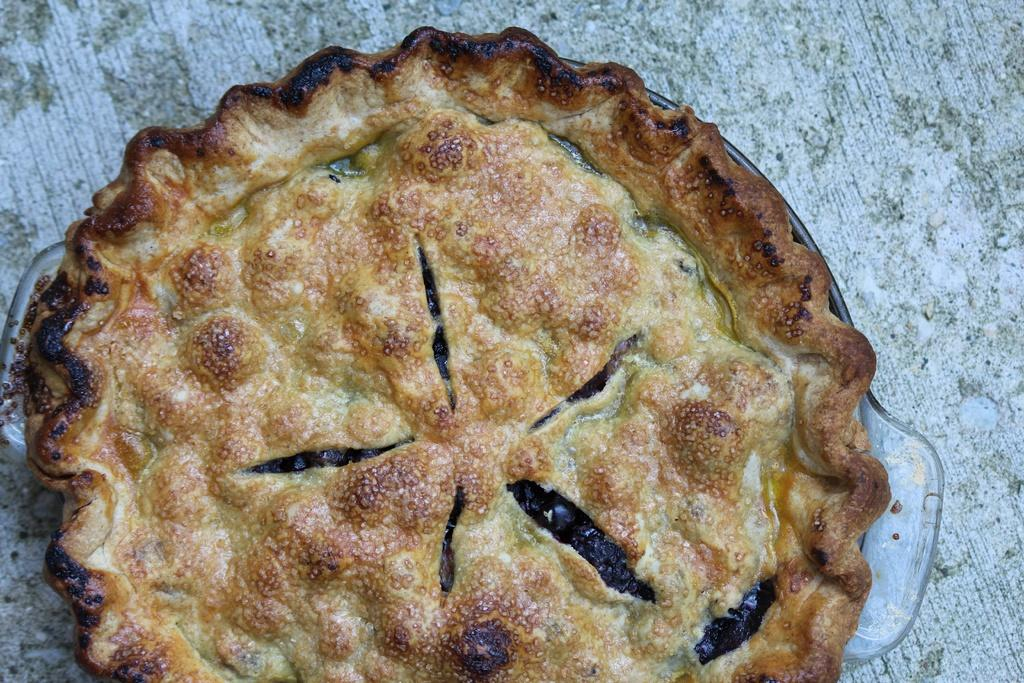What type of pie is visible in the image? There is a blueberry pie in the image. How is the blueberry pie contained or displayed? The blueberry pie is in a glass plate. What is the glass plate resting on in the image? The glass plate is placed on a wooden board. What type of company is responsible for manufacturing the hydrant in the image? There is no hydrant present in the image, so it is not possible to determine which company might be responsible for manufacturing it. 